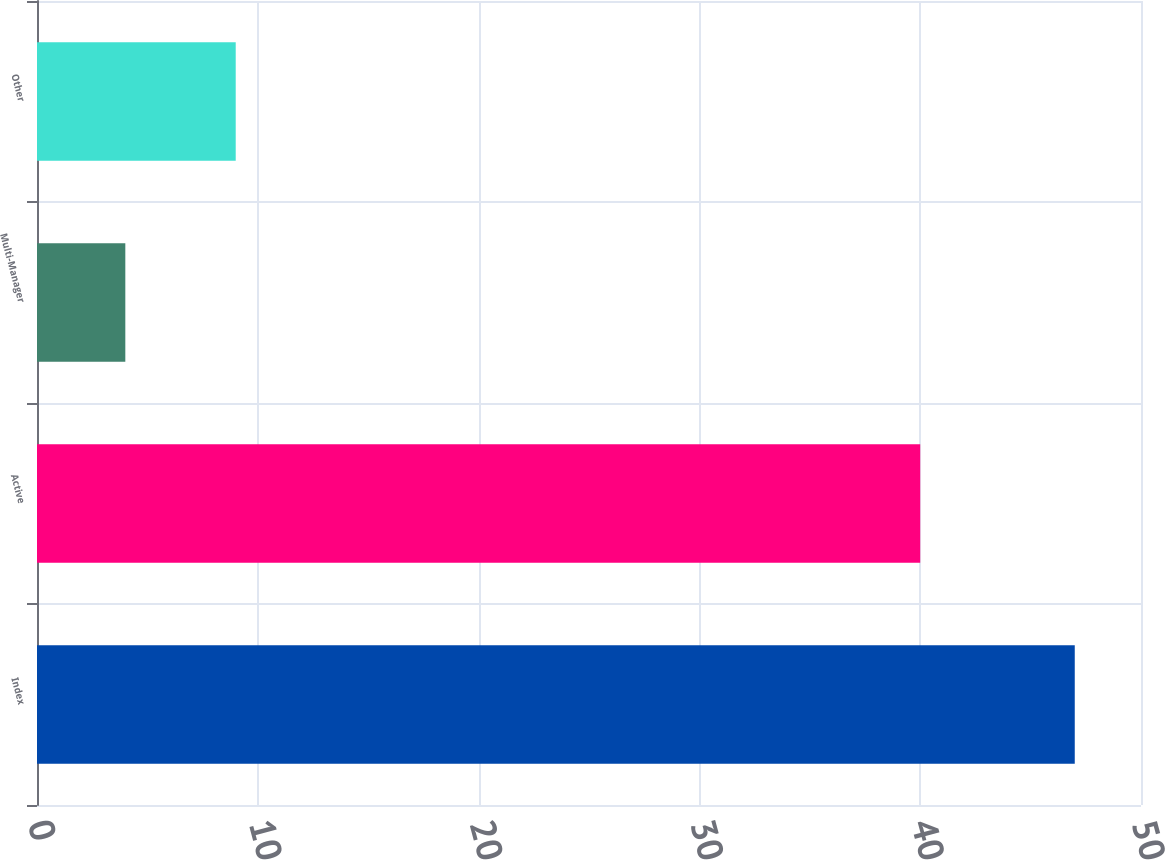Convert chart. <chart><loc_0><loc_0><loc_500><loc_500><bar_chart><fcel>Index<fcel>Active<fcel>Multi-Manager<fcel>Other<nl><fcel>47<fcel>40<fcel>4<fcel>9<nl></chart> 